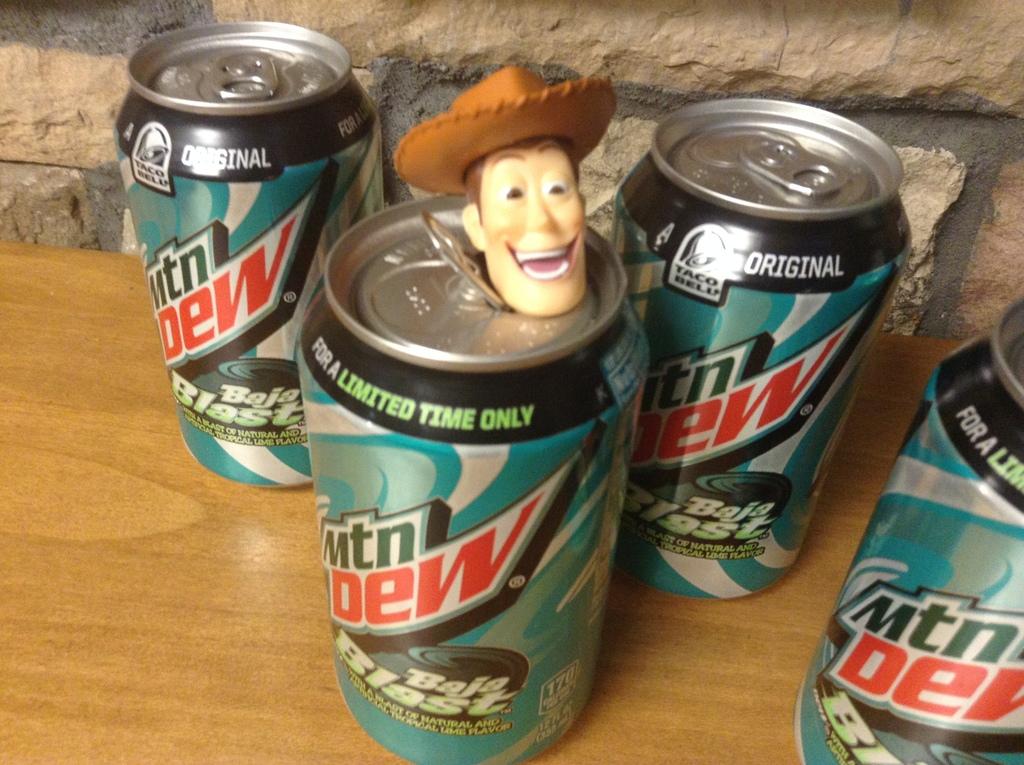What soda is that?
Give a very brief answer. Mountain dew. What fast food restaurant is advertised on these cans?
Ensure brevity in your answer.  Taco bell. 